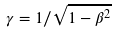<formula> <loc_0><loc_0><loc_500><loc_500>\gamma = 1 / \sqrt { 1 - \beta ^ { 2 } }</formula> 